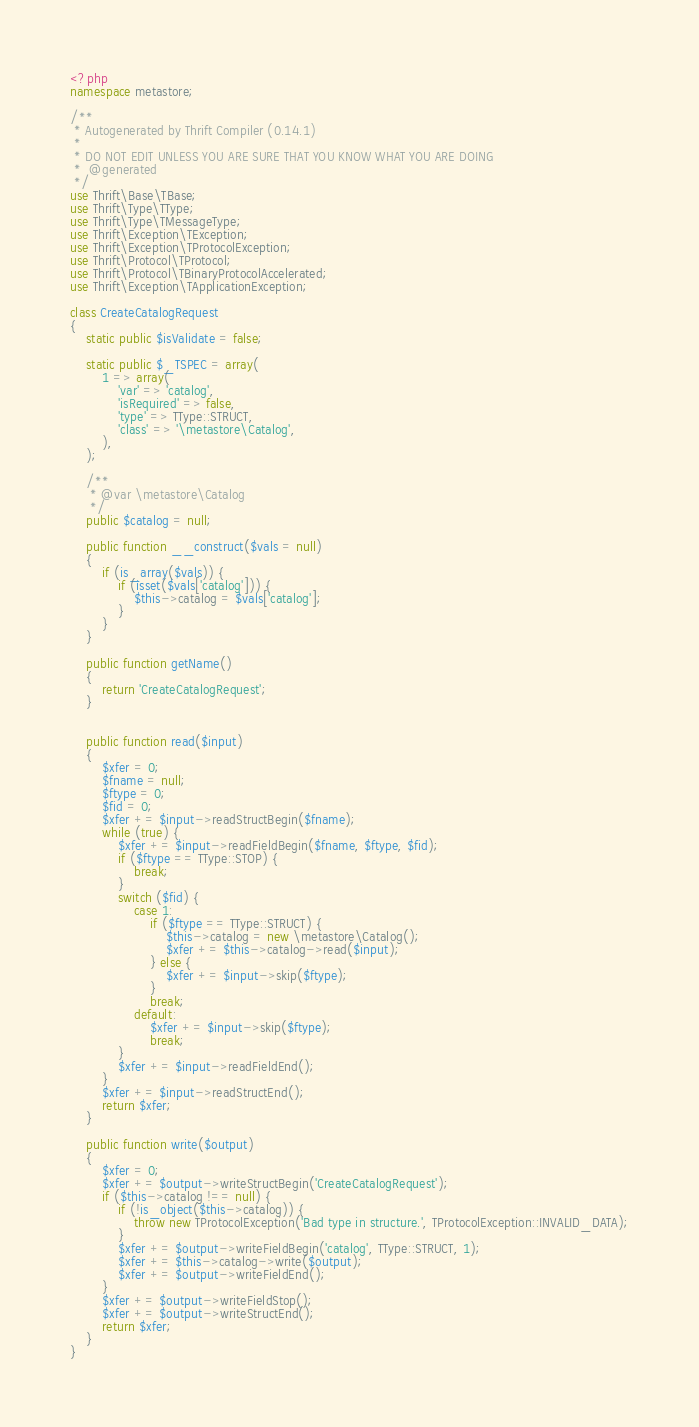<code> <loc_0><loc_0><loc_500><loc_500><_PHP_><?php
namespace metastore;

/**
 * Autogenerated by Thrift Compiler (0.14.1)
 *
 * DO NOT EDIT UNLESS YOU ARE SURE THAT YOU KNOW WHAT YOU ARE DOING
 *  @generated
 */
use Thrift\Base\TBase;
use Thrift\Type\TType;
use Thrift\Type\TMessageType;
use Thrift\Exception\TException;
use Thrift\Exception\TProtocolException;
use Thrift\Protocol\TProtocol;
use Thrift\Protocol\TBinaryProtocolAccelerated;
use Thrift\Exception\TApplicationException;

class CreateCatalogRequest
{
    static public $isValidate = false;

    static public $_TSPEC = array(
        1 => array(
            'var' => 'catalog',
            'isRequired' => false,
            'type' => TType::STRUCT,
            'class' => '\metastore\Catalog',
        ),
    );

    /**
     * @var \metastore\Catalog
     */
    public $catalog = null;

    public function __construct($vals = null)
    {
        if (is_array($vals)) {
            if (isset($vals['catalog'])) {
                $this->catalog = $vals['catalog'];
            }
        }
    }

    public function getName()
    {
        return 'CreateCatalogRequest';
    }


    public function read($input)
    {
        $xfer = 0;
        $fname = null;
        $ftype = 0;
        $fid = 0;
        $xfer += $input->readStructBegin($fname);
        while (true) {
            $xfer += $input->readFieldBegin($fname, $ftype, $fid);
            if ($ftype == TType::STOP) {
                break;
            }
            switch ($fid) {
                case 1:
                    if ($ftype == TType::STRUCT) {
                        $this->catalog = new \metastore\Catalog();
                        $xfer += $this->catalog->read($input);
                    } else {
                        $xfer += $input->skip($ftype);
                    }
                    break;
                default:
                    $xfer += $input->skip($ftype);
                    break;
            }
            $xfer += $input->readFieldEnd();
        }
        $xfer += $input->readStructEnd();
        return $xfer;
    }

    public function write($output)
    {
        $xfer = 0;
        $xfer += $output->writeStructBegin('CreateCatalogRequest');
        if ($this->catalog !== null) {
            if (!is_object($this->catalog)) {
                throw new TProtocolException('Bad type in structure.', TProtocolException::INVALID_DATA);
            }
            $xfer += $output->writeFieldBegin('catalog', TType::STRUCT, 1);
            $xfer += $this->catalog->write($output);
            $xfer += $output->writeFieldEnd();
        }
        $xfer += $output->writeFieldStop();
        $xfer += $output->writeStructEnd();
        return $xfer;
    }
}
</code> 